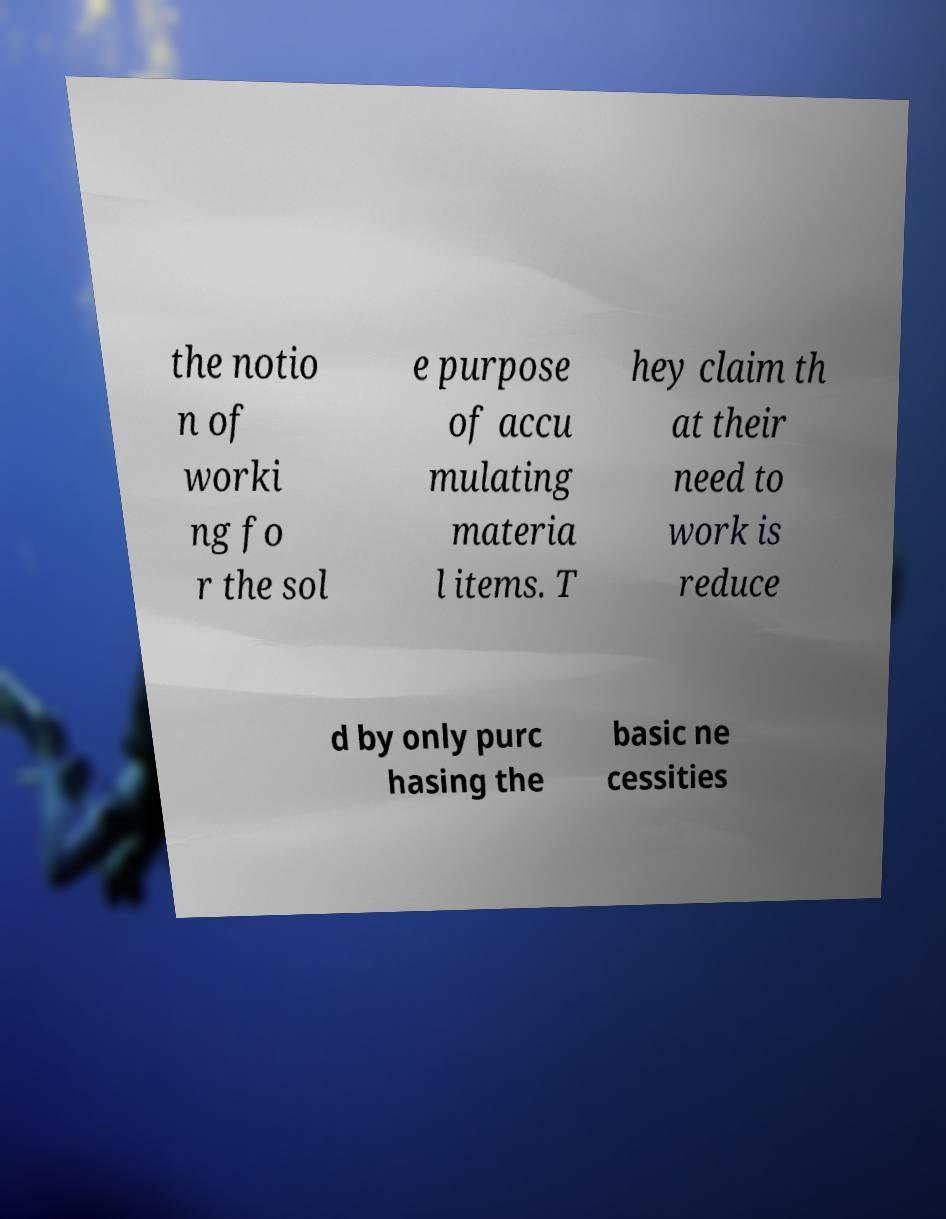I need the written content from this picture converted into text. Can you do that? the notio n of worki ng fo r the sol e purpose of accu mulating materia l items. T hey claim th at their need to work is reduce d by only purc hasing the basic ne cessities 